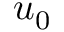<formula> <loc_0><loc_0><loc_500><loc_500>u _ { 0 }</formula> 